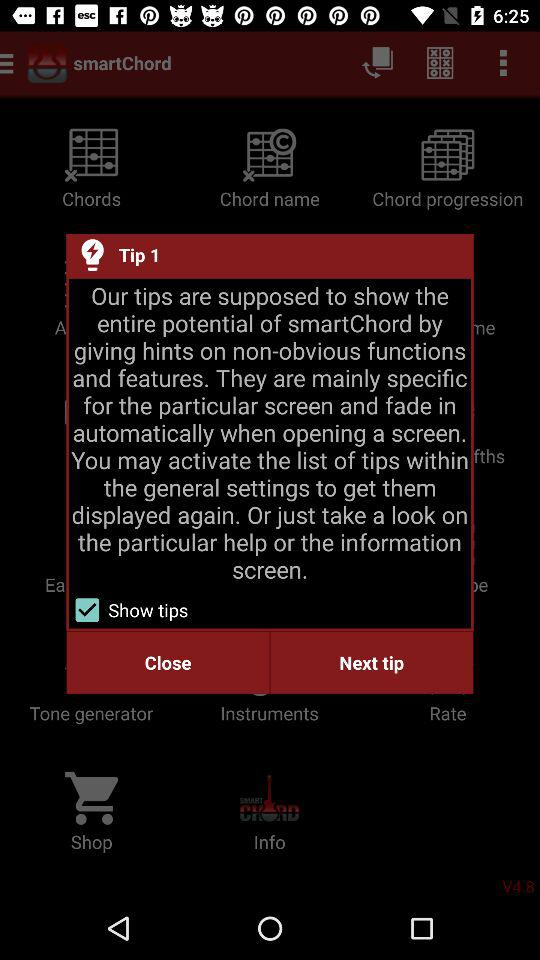What is the status of "Show tips"? The status is "on". 